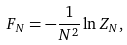<formula> <loc_0><loc_0><loc_500><loc_500>F _ { N } = - \frac { 1 } { N ^ { 2 } } \ln Z _ { N } ,</formula> 